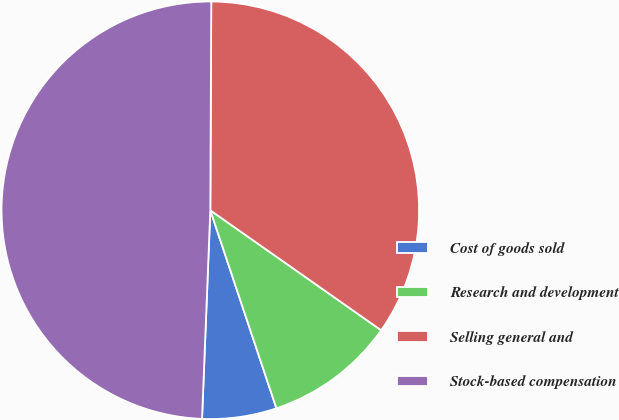Convert chart. <chart><loc_0><loc_0><loc_500><loc_500><pie_chart><fcel>Cost of goods sold<fcel>Research and development<fcel>Selling general and<fcel>Stock-based compensation<nl><fcel>5.76%<fcel>10.13%<fcel>34.67%<fcel>49.44%<nl></chart> 